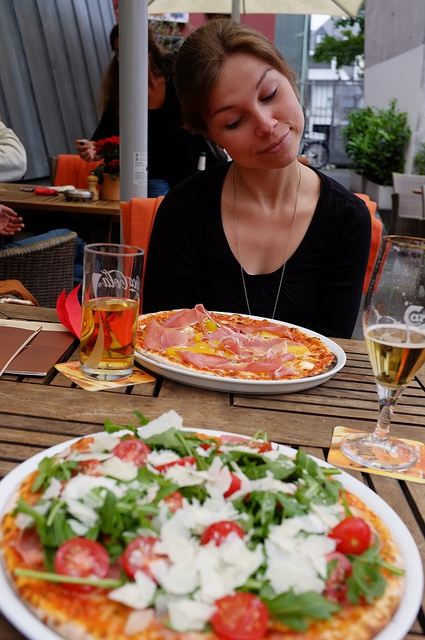Describe the objects in this image and their specific colors. I can see pizza in gray, lightgray, darkgreen, darkgray, and olive tones, people in gray, black, brown, maroon, and lightpink tones, dining table in gray, black, and brown tones, pizza in gray, salmon, tan, and red tones, and wine glass in gray, darkgray, tan, and black tones in this image. 